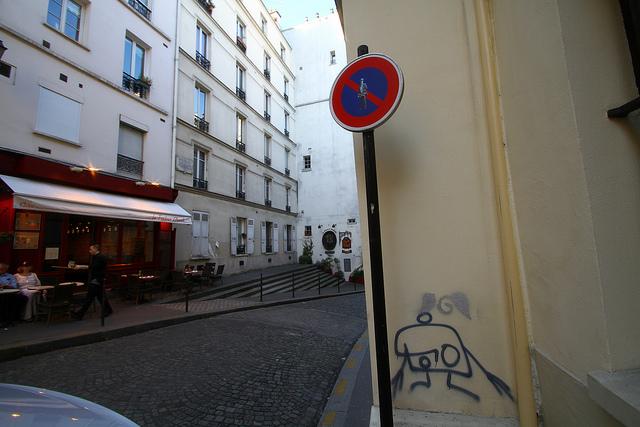What is the vivid red object in the picture?
Give a very brief answer. Sign. What store can be seen in the background?
Short answer required. Restaurant. Is this outdoors?
Write a very short answer. Yes. What color is the "walking street" sign?
Answer briefly. Red and blue. Is there a mirror above the sign?
Short answer required. No. What is on the wall?
Answer briefly. Graffiti. What is holding the signs to the wooden pole?
Write a very short answer. Screws. What is the black paved surface?
Quick response, please. Road. Are there any people on the sidewalk?
Short answer required. Yes. Is it daytime?
Answer briefly. Yes. How many manhole covers are shown?
Give a very brief answer. 0. What direction are we viewing?
Be succinct. North. Where is the graffiti?
Keep it brief. Wall. Is there a sign?
Give a very brief answer. Yes. Is it a clear day?
Concise answer only. Yes. Who is on the bench?
Be succinct. No 1. Where is this?
Be succinct. City. 